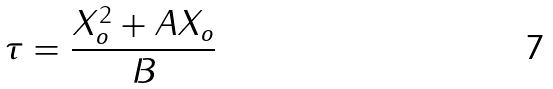Convert formula to latex. <formula><loc_0><loc_0><loc_500><loc_500>\tau = \frac { X _ { o } ^ { 2 } + A X _ { o } } { B }</formula> 